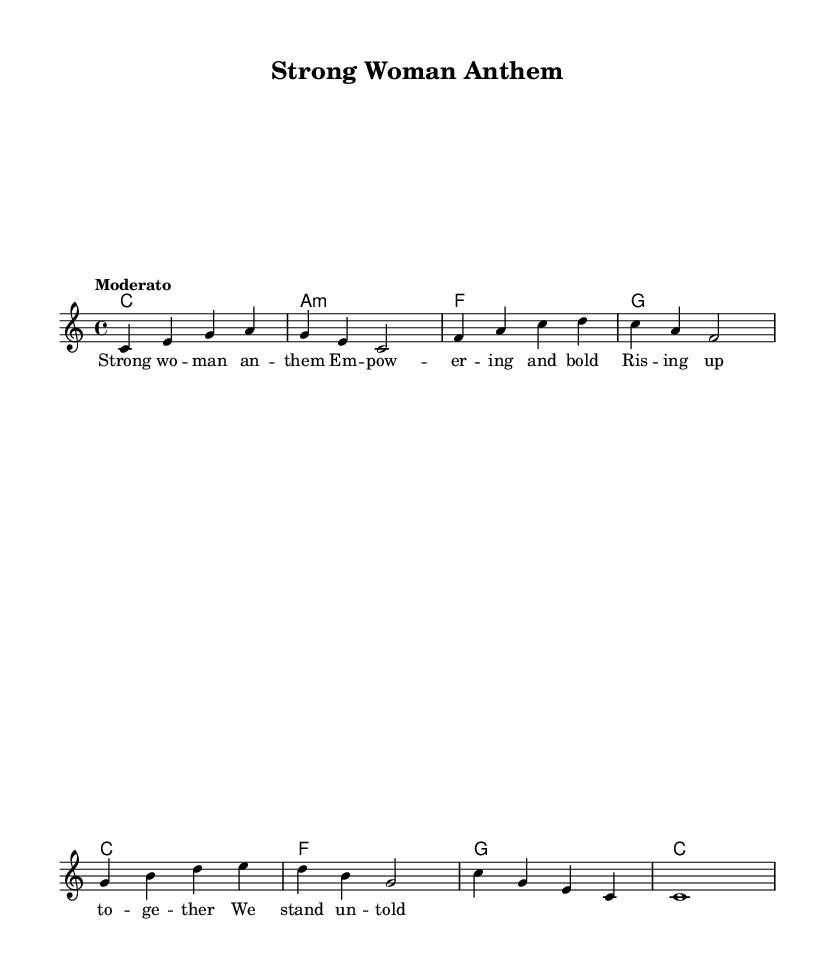What is the key signature of this music? The key signature is indicated at the beginning of the staff. It shows C major, which has no sharps or flats.
Answer: C major What is the time signature of this music? The time signature is found at the beginning of the score and it indicates 4/4. This means there are four beats per measure and a quarter note receives one beat.
Answer: 4/4 What is the tempo marking for this piece? The tempo marking is indicated at the start of the score and it states "Moderato", which indicates a moderate tempo.
Answer: Moderato How many measures are in the melody? To find the number of measures, I counted each grouping separated by the vertical lines, which divides the music into measures. There are a total of eight measures.
Answer: 8 What type of musical form does this anthem convey? The structure includes repeating sections and an uplifting message, which is characteristic of an anthem. Analyzing the lyrics and overall flow, it reinforces the empowering theme typical of pop anthems.
Answer: Anthem What is the highest note in the melody? The highest note can be determined by looking at the notes in the melody line. The note "b" appears in measure five, which is the highest pitch present.
Answer: b Which emotions does the title of this song evoke? The title "Strong Woman Anthem" suggests themes of empowerment, confidence, and unity among women. The context of the lyrics contributes to an uplifting and inspiring emotion.
Answer: Empowerment 